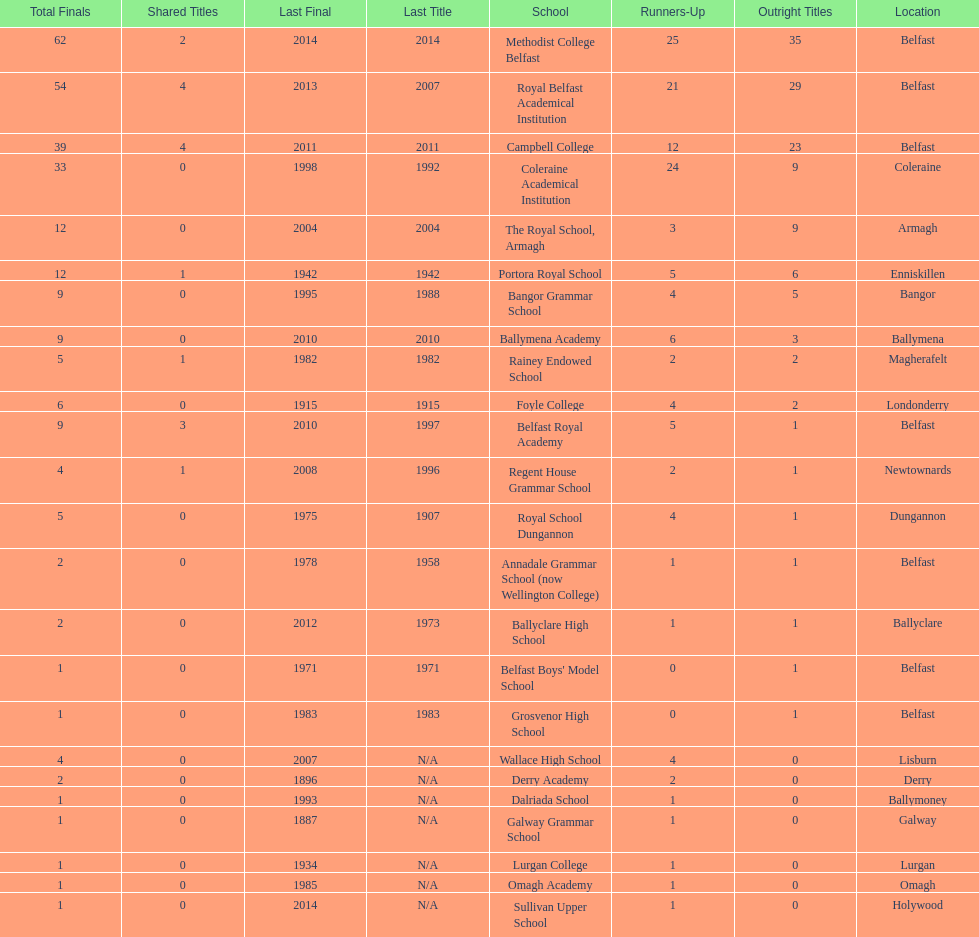Who holds the latest title victory, campbell college or regent house grammar school? Campbell College. 